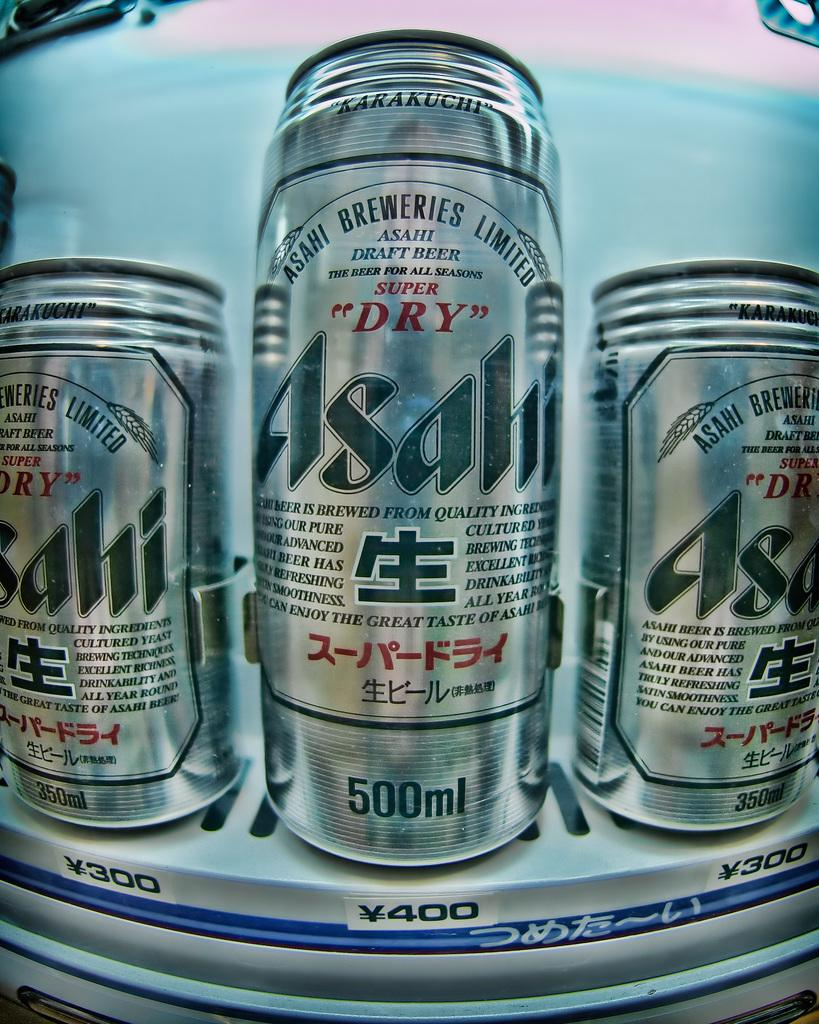<image>
Share a concise interpretation of the image provided. Three cans of Dry Asahi are on a shelf. 